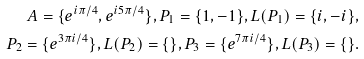Convert formula to latex. <formula><loc_0><loc_0><loc_500><loc_500>A = \{ e ^ { i \pi / 4 } , e ^ { i 5 \pi / 4 } \} , P _ { 1 } = \{ 1 , - 1 \} , L ( P _ { 1 } ) = \{ i , - i \} , \\ P _ { 2 } = \{ e ^ { 3 \pi i / 4 } \} , L ( P _ { 2 } ) = \{ \} , P _ { 3 } = \{ e ^ { 7 \pi i / 4 } \} , L ( P _ { 3 } ) = \{ \} .</formula> 